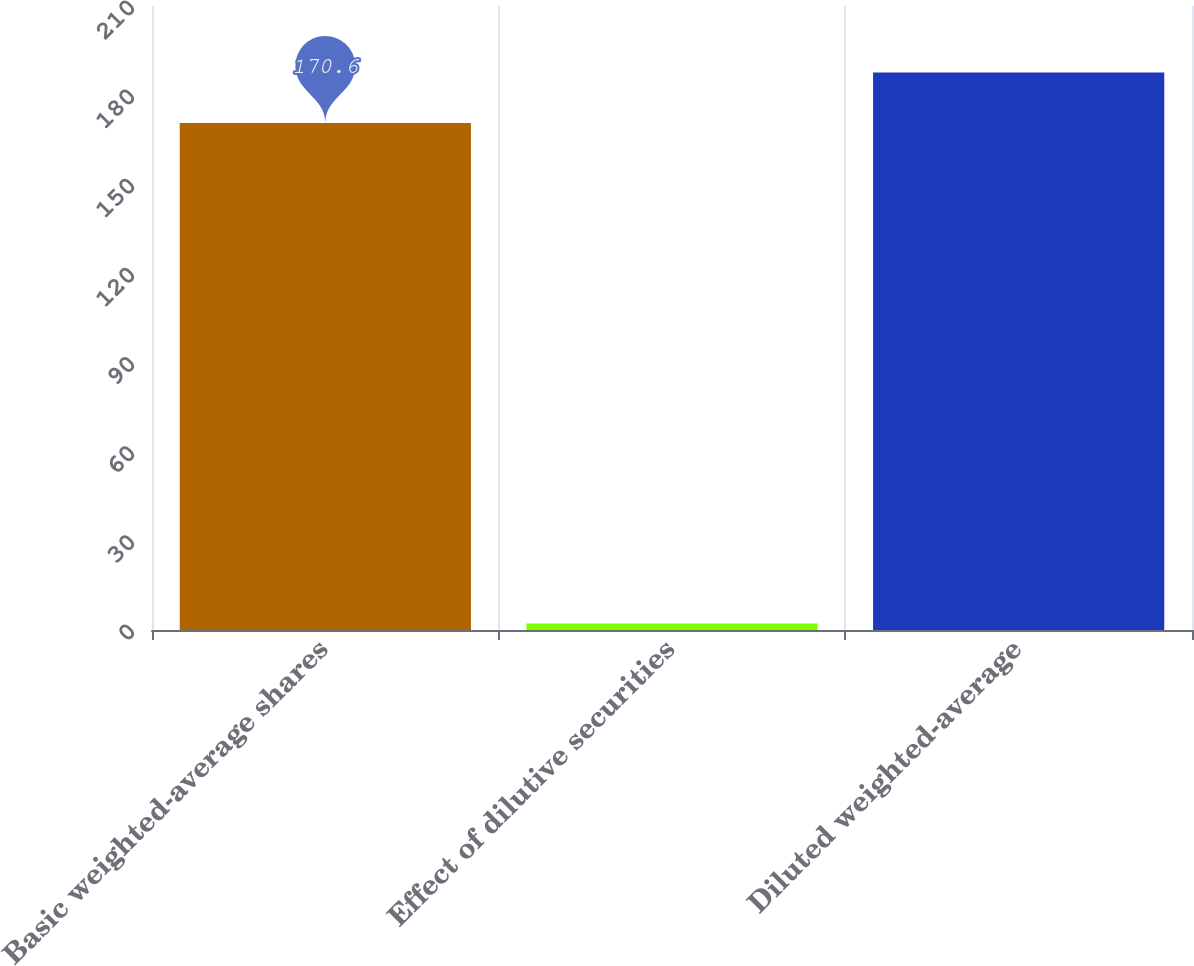<chart> <loc_0><loc_0><loc_500><loc_500><bar_chart><fcel>Basic weighted-average shares<fcel>Effect of dilutive securities<fcel>Diluted weighted-average<nl><fcel>170.6<fcel>2.2<fcel>187.66<nl></chart> 